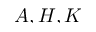<formula> <loc_0><loc_0><loc_500><loc_500>A , H , K</formula> 